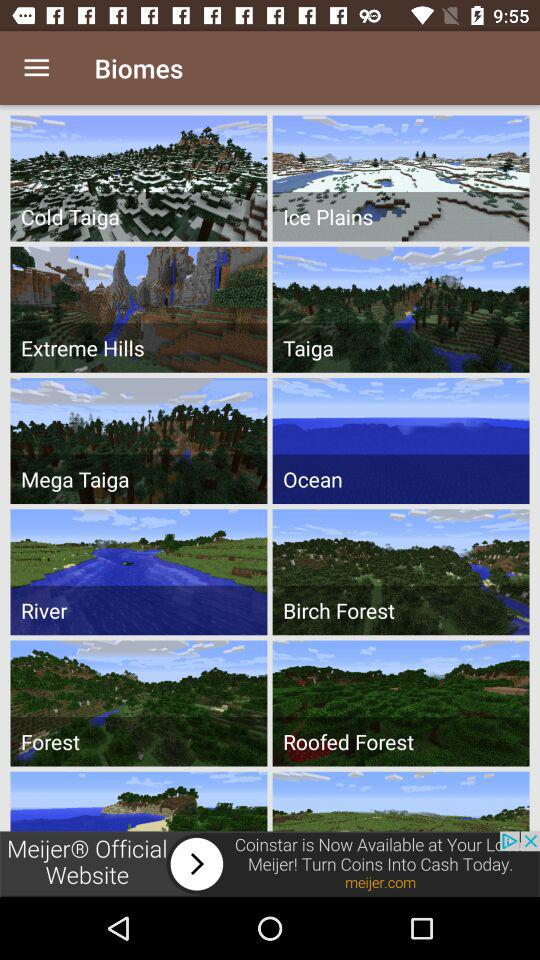What are the available biomes? The available biomes are Cold Taiga, Ice Plains, Extreme Hills, Taiga, Mega Taiga, Ocean, River, Birch Forest, Forest and Roofed Forest. 